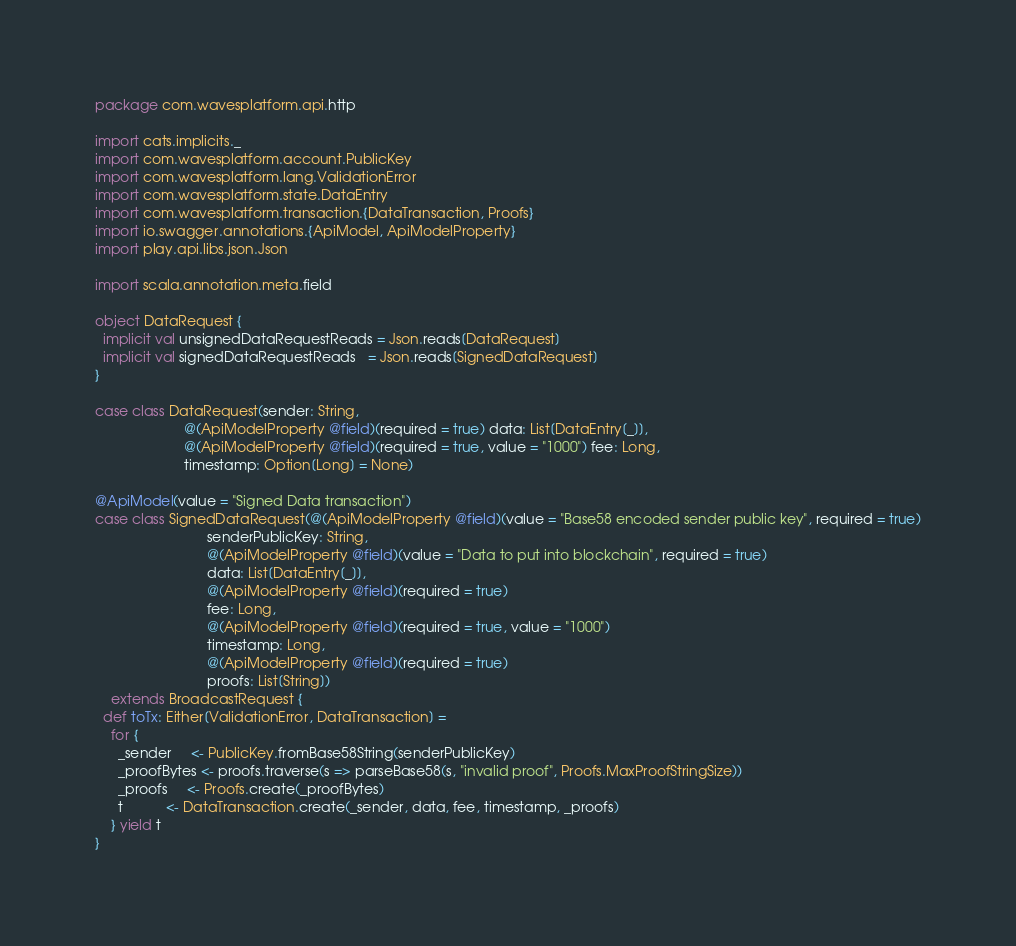<code> <loc_0><loc_0><loc_500><loc_500><_Scala_>package com.wavesplatform.api.http

import cats.implicits._
import com.wavesplatform.account.PublicKey
import com.wavesplatform.lang.ValidationError
import com.wavesplatform.state.DataEntry
import com.wavesplatform.transaction.{DataTransaction, Proofs}
import io.swagger.annotations.{ApiModel, ApiModelProperty}
import play.api.libs.json.Json

import scala.annotation.meta.field

object DataRequest {
  implicit val unsignedDataRequestReads = Json.reads[DataRequest]
  implicit val signedDataRequestReads   = Json.reads[SignedDataRequest]
}

case class DataRequest(sender: String,
                       @(ApiModelProperty @field)(required = true) data: List[DataEntry[_]],
                       @(ApiModelProperty @field)(required = true, value = "1000") fee: Long,
                       timestamp: Option[Long] = None)

@ApiModel(value = "Signed Data transaction")
case class SignedDataRequest(@(ApiModelProperty @field)(value = "Base58 encoded sender public key", required = true)
                             senderPublicKey: String,
                             @(ApiModelProperty @field)(value = "Data to put into blockchain", required = true)
                             data: List[DataEntry[_]],
                             @(ApiModelProperty @field)(required = true)
                             fee: Long,
                             @(ApiModelProperty @field)(required = true, value = "1000")
                             timestamp: Long,
                             @(ApiModelProperty @field)(required = true)
                             proofs: List[String])
    extends BroadcastRequest {
  def toTx: Either[ValidationError, DataTransaction] =
    for {
      _sender     <- PublicKey.fromBase58String(senderPublicKey)
      _proofBytes <- proofs.traverse(s => parseBase58(s, "invalid proof", Proofs.MaxProofStringSize))
      _proofs     <- Proofs.create(_proofBytes)
      t           <- DataTransaction.create(_sender, data, fee, timestamp, _proofs)
    } yield t
}
</code> 